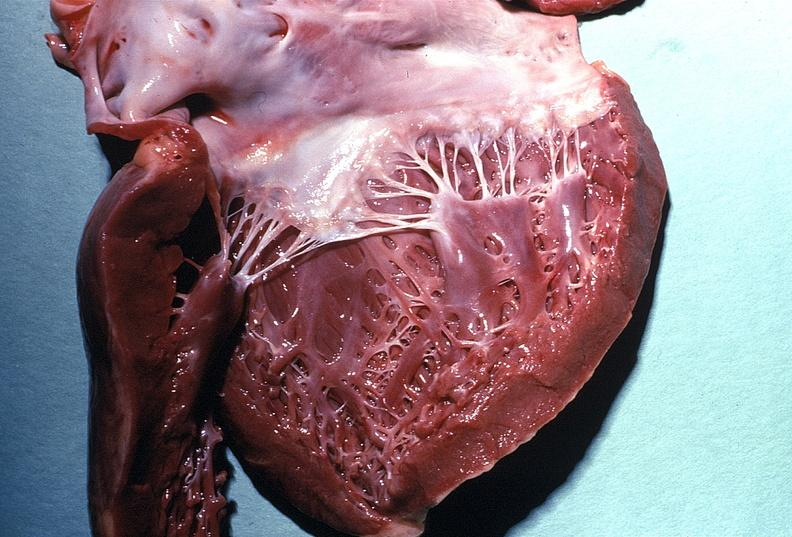s intraductal papillomatosis present?
Answer the question using a single word or phrase. No 